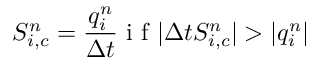Convert formula to latex. <formula><loc_0><loc_0><loc_500><loc_500>S _ { i , c } ^ { n } = \frac { q _ { i } ^ { n } } { \Delta t } i f | \Delta t S _ { i , c } ^ { n } | > | q _ { i } ^ { n } |</formula> 